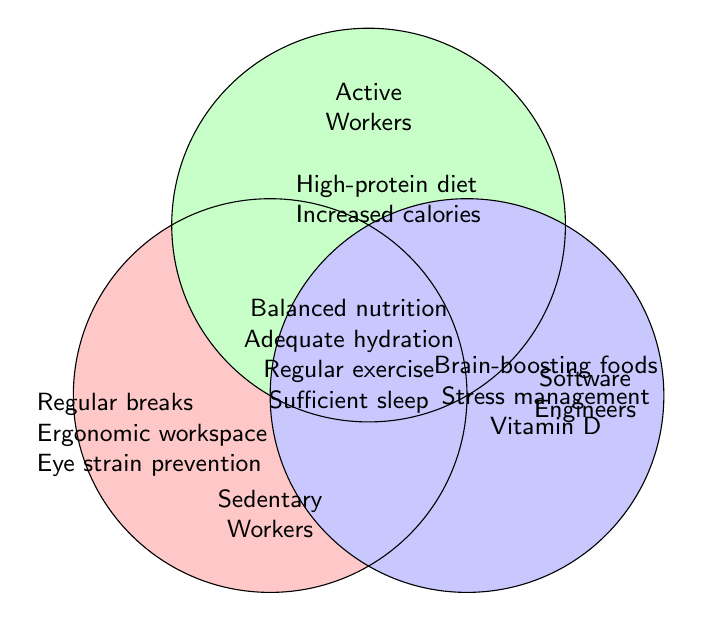What are two measures specific to Sedentary Workers? Identify items listed only under Sedentary Workers. The measures mentioned are Regular breaks and Ergonomic workspace.
Answer: Regular breaks, Ergonomic workspace Which items are shared by both Sedentary and Active Workers? Look for items listed under the category "Both" as these items apply to Sedentary and Active workers.
Answer: Balanced nutrition, Adequate hydration, Regular exercise, Sufficient sleep Which group has recommendations related to mental health? Identify the group to which Brain-boosting foods and Stress management belong based on their category listing. These recommendations are under Software Engineers.
Answer: Software Engineers What's a feature unique to Active Workers not shared with any other group? Identify items listed under Active Workers that are not also listed under Both. High-protein diet and Increased calorie intake are unique to Active Workers.
Answer: High-protein diet, Increased calorie intake Which category includes Vitamin D supplements? Identify the category where Vitamin D supplements are listed. This falls under Software Engineers.
Answer: Software Engineers 